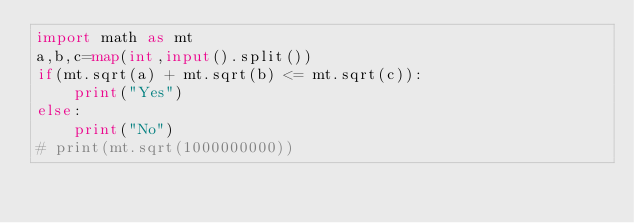Convert code to text. <code><loc_0><loc_0><loc_500><loc_500><_Python_>import math as mt
a,b,c=map(int,input().split())
if(mt.sqrt(a) + mt.sqrt(b) <= mt.sqrt(c)):
    print("Yes")
else:
    print("No")
# print(mt.sqrt(1000000000))</code> 